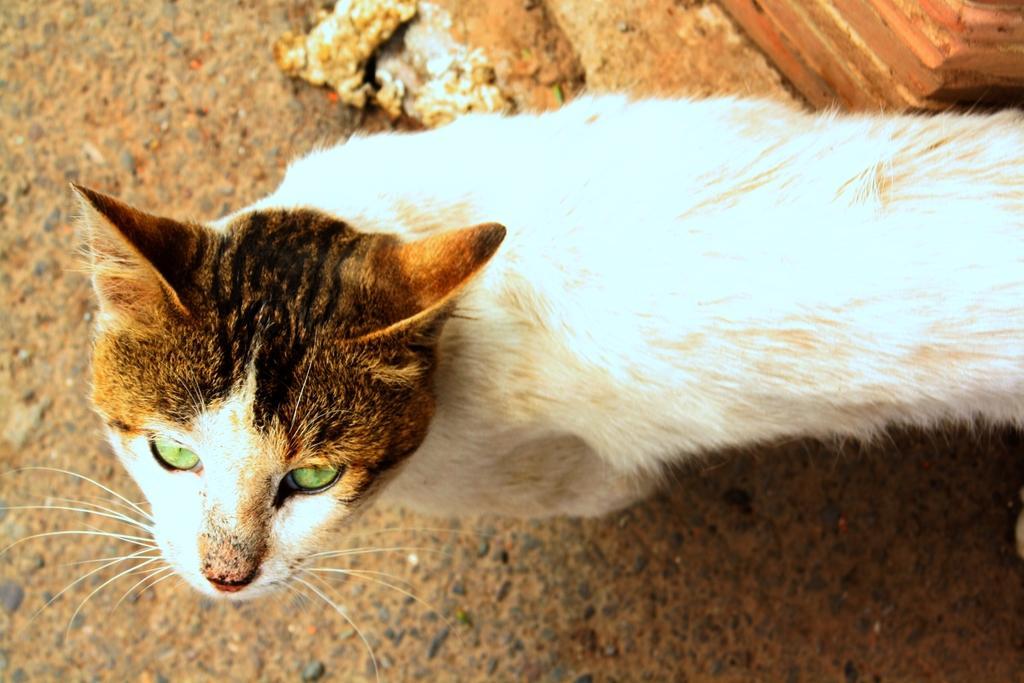Can you describe this image briefly? In this image, we can see a cat which is colored white and brown. 